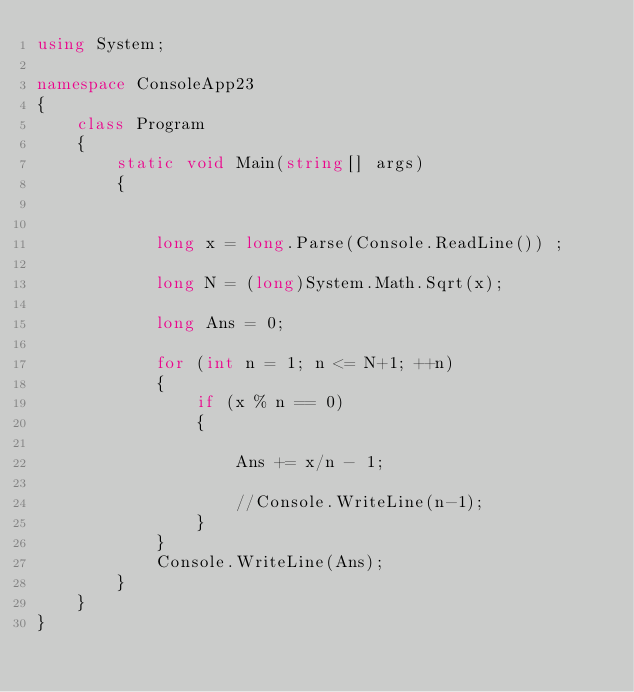<code> <loc_0><loc_0><loc_500><loc_500><_C#_>using System;

namespace ConsoleApp23
{
    class Program
    {
        static void Main(string[] args)
        {


            long x = long.Parse(Console.ReadLine()) ;

            long N = (long)System.Math.Sqrt(x);

            long Ans = 0;

            for (int n = 1; n <= N+1; ++n)
            {
                if (x % n == 0)
                {
                    
                    Ans += x/n - 1;

                    //Console.WriteLine(n-1);
                }
            }
            Console.WriteLine(Ans);
        }
    }
}</code> 